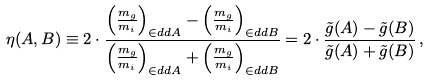Convert formula to latex. <formula><loc_0><loc_0><loc_500><loc_500>\eta ( A , B ) \equiv 2 \cdot \frac { \left ( \frac { m _ { g } } { m _ { i } } \right ) _ { \in d d { A } } - \left ( \frac { m _ { g } } { m _ { i } } \right ) _ { \in d d { B } } } { \left ( \frac { m _ { g } } { m _ { i } } \right ) _ { \in d d { A } } + \left ( \frac { m _ { g } } { m _ { i } } \right ) _ { \in d d { B } } } = 2 \cdot \frac { \tilde { g } ( A ) - \tilde { g } ( B ) } { \tilde { g } ( A ) + \tilde { g } ( B ) } \, ,</formula> 